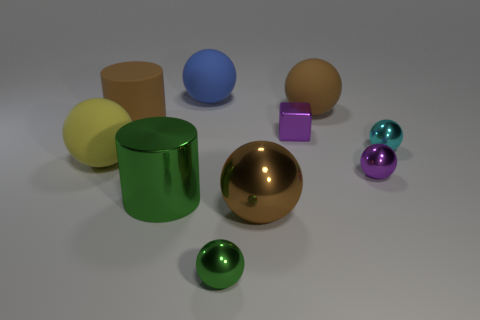What is the shape of the blue thing? The shape of the blue object in the image is a sphere. It has a smooth and continuous surface with no edges or vertices, characteristic of a perfect 3D round shape. 